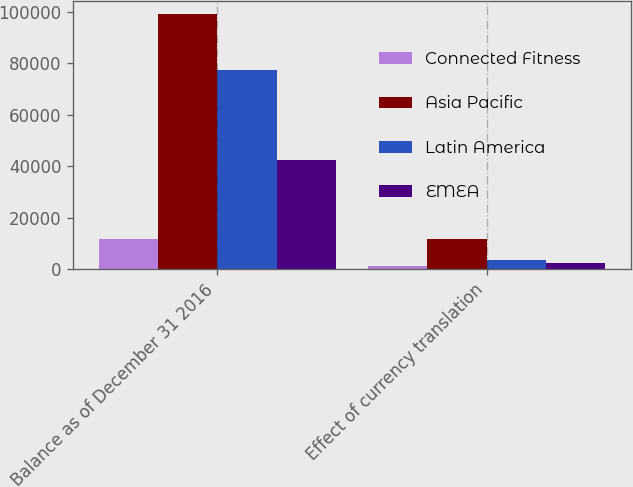Convert chart to OTSL. <chart><loc_0><loc_0><loc_500><loc_500><stacked_bar_chart><ecel><fcel>Balance as of December 31 2016<fcel>Effect of currency translation<nl><fcel>Connected Fitness<fcel>11910<fcel>1132<nl><fcel>Asia Pacific<fcel>99245<fcel>11910<nl><fcel>Latin America<fcel>77586<fcel>3737<nl><fcel>EMEA<fcel>42436<fcel>2305<nl></chart> 